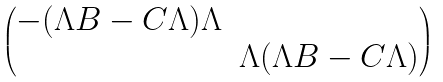Convert formula to latex. <formula><loc_0><loc_0><loc_500><loc_500>\begin{pmatrix} - ( \Lambda B - C \Lambda ) \Lambda \\ & \Lambda ( \Lambda B - C \Lambda ) \end{pmatrix}</formula> 